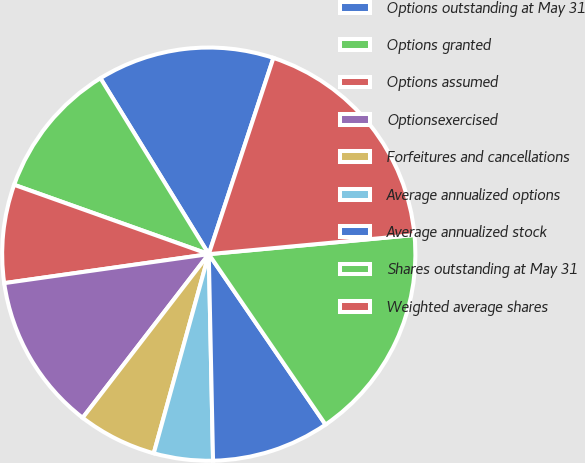<chart> <loc_0><loc_0><loc_500><loc_500><pie_chart><fcel>Options outstanding at May 31<fcel>Options granted<fcel>Options assumed<fcel>Optionsexercised<fcel>Forfeitures and cancellations<fcel>Average annualized options<fcel>Average annualized stock<fcel>Shares outstanding at May 31<fcel>Weighted average shares<nl><fcel>13.85%<fcel>10.77%<fcel>7.69%<fcel>12.31%<fcel>6.16%<fcel>4.62%<fcel>9.23%<fcel>16.92%<fcel>18.46%<nl></chart> 